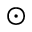<formula> <loc_0><loc_0><loc_500><loc_500>\odot</formula> 